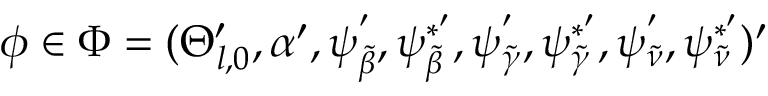Convert formula to latex. <formula><loc_0><loc_0><loc_500><loc_500>\phi \in \Phi = ( \Theta _ { l , 0 } ^ { \prime } , \alpha ^ { \prime } , \psi _ { \tilde { \beta } } ^ { ^ { \prime } } , \psi _ { \tilde { \beta } } ^ { * ^ { \prime } } , \psi _ { \tilde { \gamma } } ^ { ^ { \prime } } , \psi _ { \tilde { \gamma } } ^ { * ^ { \prime } } , \psi _ { \tilde { \nu } } ^ { ^ { \prime } } , \psi _ { \tilde { \nu } } ^ { * ^ { \prime } } ) ^ { \prime }</formula> 